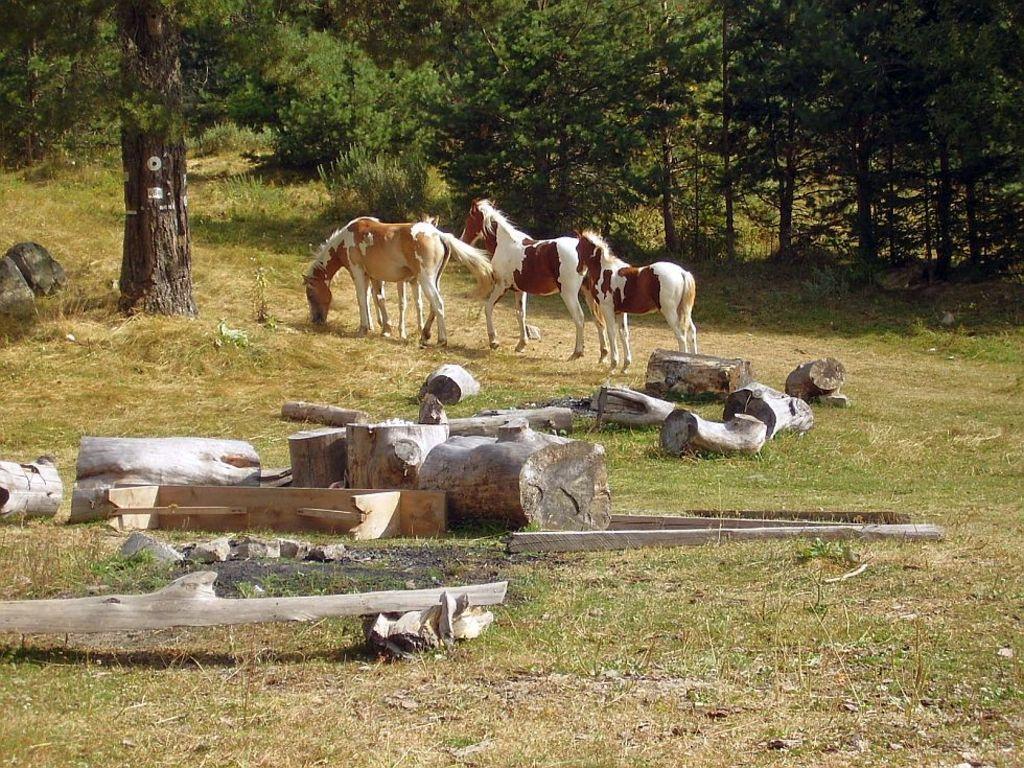Please provide a concise description of this image. In this image there are three horses walking on the ground. There is grass on the ground. In the foreground there are logs of wood. In the background there are plants and trees. 